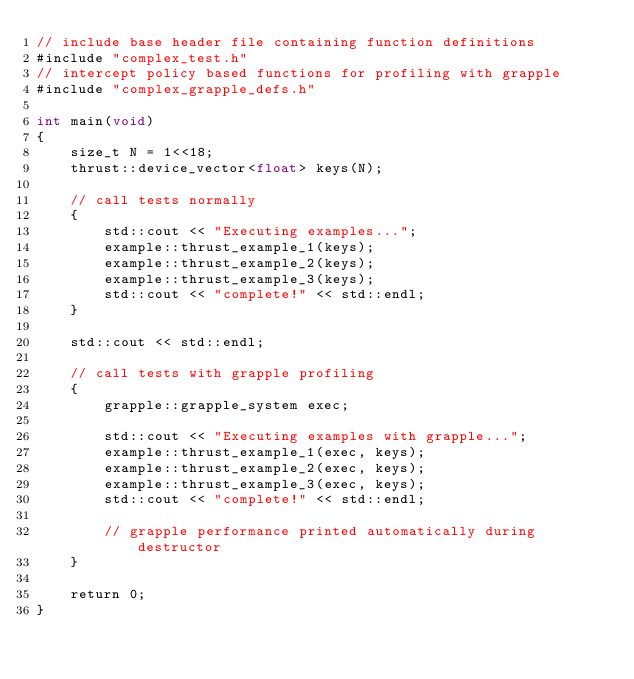Convert code to text. <code><loc_0><loc_0><loc_500><loc_500><_Cuda_>// include base header file containing function definitions
#include "complex_test.h"
// intercept policy based functions for profiling with grapple
#include "complex_grapple_defs.h"

int main(void)
{
    size_t N = 1<<18;
    thrust::device_vector<float> keys(N);

    // call tests normally
    {
        std::cout << "Executing examples...";
        example::thrust_example_1(keys);
        example::thrust_example_2(keys);
        example::thrust_example_3(keys);
        std::cout << "complete!" << std::endl;
    }

    std::cout << std::endl;

    // call tests with grapple profiling
    {
        grapple::grapple_system exec;

        std::cout << "Executing examples with grapple...";
        example::thrust_example_1(exec, keys);
        example::thrust_example_2(exec, keys);
        example::thrust_example_3(exec, keys);
        std::cout << "complete!" << std::endl;

        // grapple performance printed automatically during destructor
    }

    return 0;
}


</code> 